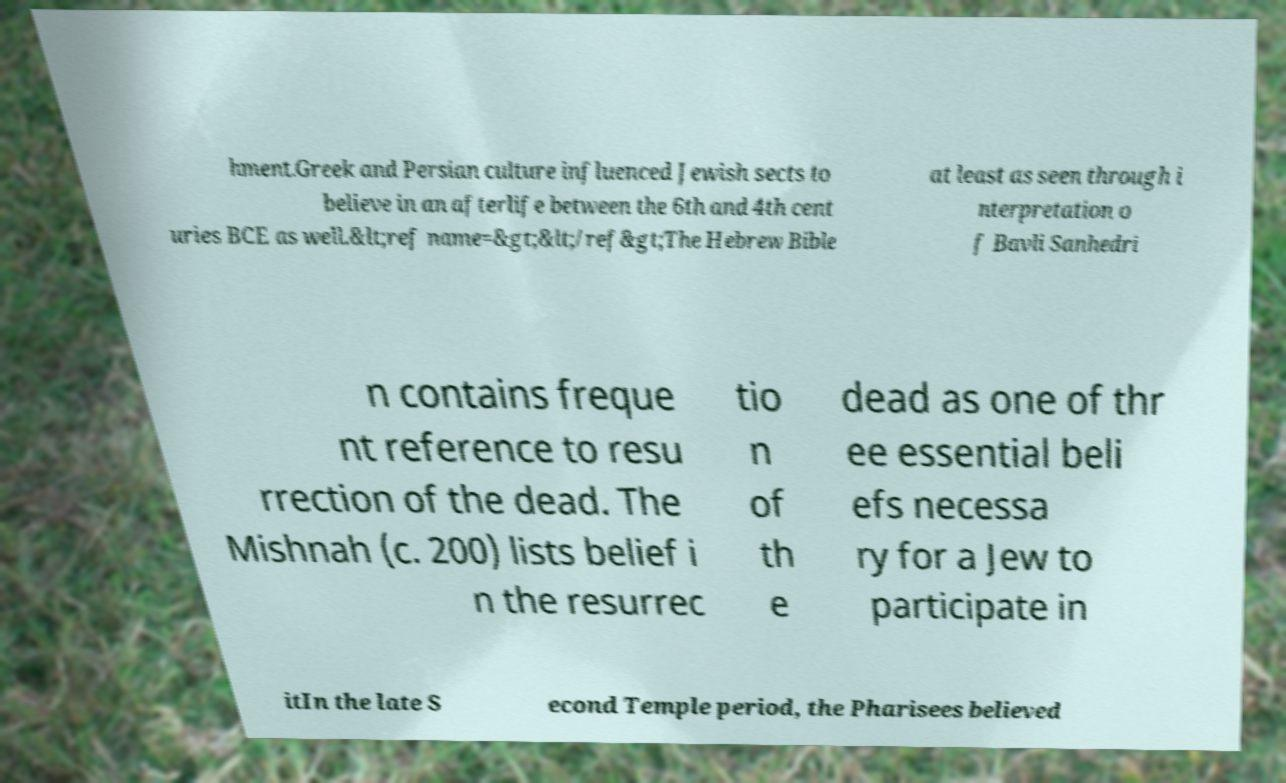Please read and relay the text visible in this image. What does it say? hment.Greek and Persian culture influenced Jewish sects to believe in an afterlife between the 6th and 4th cent uries BCE as well.&lt;ref name=&gt;&lt;/ref&gt;The Hebrew Bible at least as seen through i nterpretation o f Bavli Sanhedri n contains freque nt reference to resu rrection of the dead. The Mishnah (c. 200) lists belief i n the resurrec tio n of th e dead as one of thr ee essential beli efs necessa ry for a Jew to participate in itIn the late S econd Temple period, the Pharisees believed 